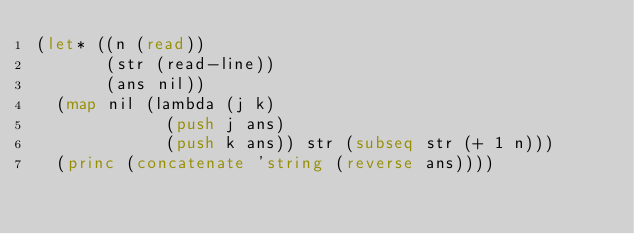<code> <loc_0><loc_0><loc_500><loc_500><_Lisp_>(let* ((n (read))
       (str (read-line))
       (ans nil))
  (map nil (lambda (j k)
             (push j ans)
             (push k ans)) str (subseq str (+ 1 n)))
  (princ (concatenate 'string (reverse ans))))</code> 